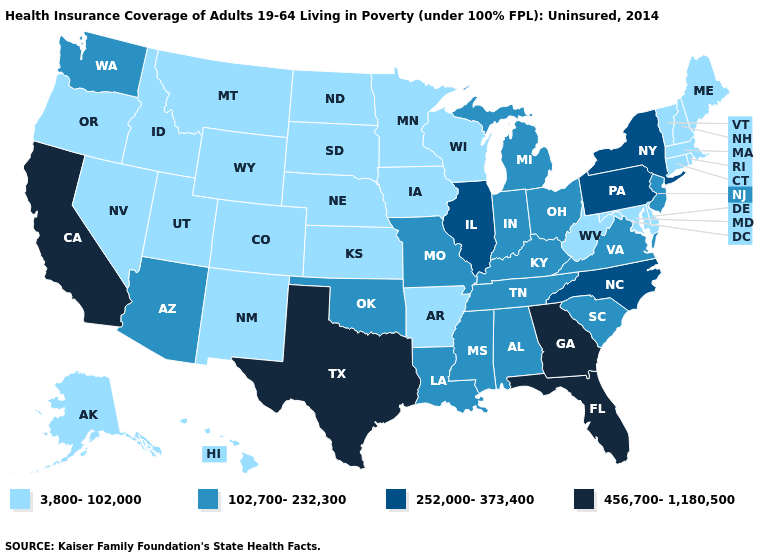What is the value of New Jersey?
Answer briefly. 102,700-232,300. Name the states that have a value in the range 102,700-232,300?
Write a very short answer. Alabama, Arizona, Indiana, Kentucky, Louisiana, Michigan, Mississippi, Missouri, New Jersey, Ohio, Oklahoma, South Carolina, Tennessee, Virginia, Washington. Does Tennessee have the lowest value in the USA?
Be succinct. No. Among the states that border Indiana , which have the lowest value?
Give a very brief answer. Kentucky, Michigan, Ohio. What is the value of New Jersey?
Answer briefly. 102,700-232,300. What is the lowest value in the USA?
Be succinct. 3,800-102,000. What is the highest value in the USA?
Keep it brief. 456,700-1,180,500. What is the value of Missouri?
Write a very short answer. 102,700-232,300. Does Kentucky have the highest value in the South?
Concise answer only. No. Which states hav the highest value in the West?
Short answer required. California. What is the lowest value in the Northeast?
Answer briefly. 3,800-102,000. Does Ohio have the highest value in the MidWest?
Give a very brief answer. No. Name the states that have a value in the range 3,800-102,000?
Short answer required. Alaska, Arkansas, Colorado, Connecticut, Delaware, Hawaii, Idaho, Iowa, Kansas, Maine, Maryland, Massachusetts, Minnesota, Montana, Nebraska, Nevada, New Hampshire, New Mexico, North Dakota, Oregon, Rhode Island, South Dakota, Utah, Vermont, West Virginia, Wisconsin, Wyoming. Among the states that border Virginia , does Kentucky have the lowest value?
Keep it brief. No. What is the lowest value in states that border Maine?
Concise answer only. 3,800-102,000. 